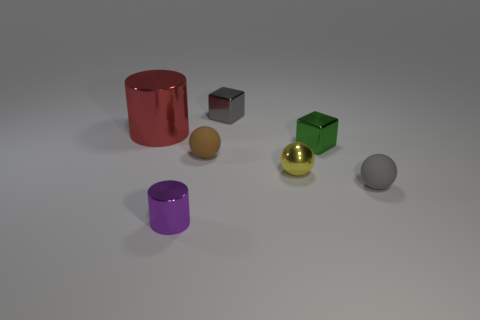Add 1 small purple matte blocks. How many objects exist? 8 Subtract all blocks. How many objects are left? 5 Add 7 big red shiny cylinders. How many big red shiny cylinders exist? 8 Subtract 0 red balls. How many objects are left? 7 Subtract all small green objects. Subtract all tiny brown rubber objects. How many objects are left? 5 Add 5 red cylinders. How many red cylinders are left? 6 